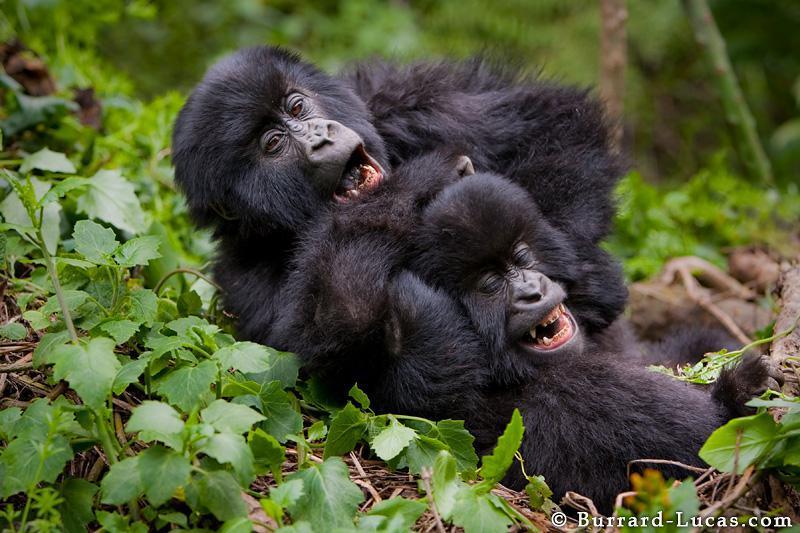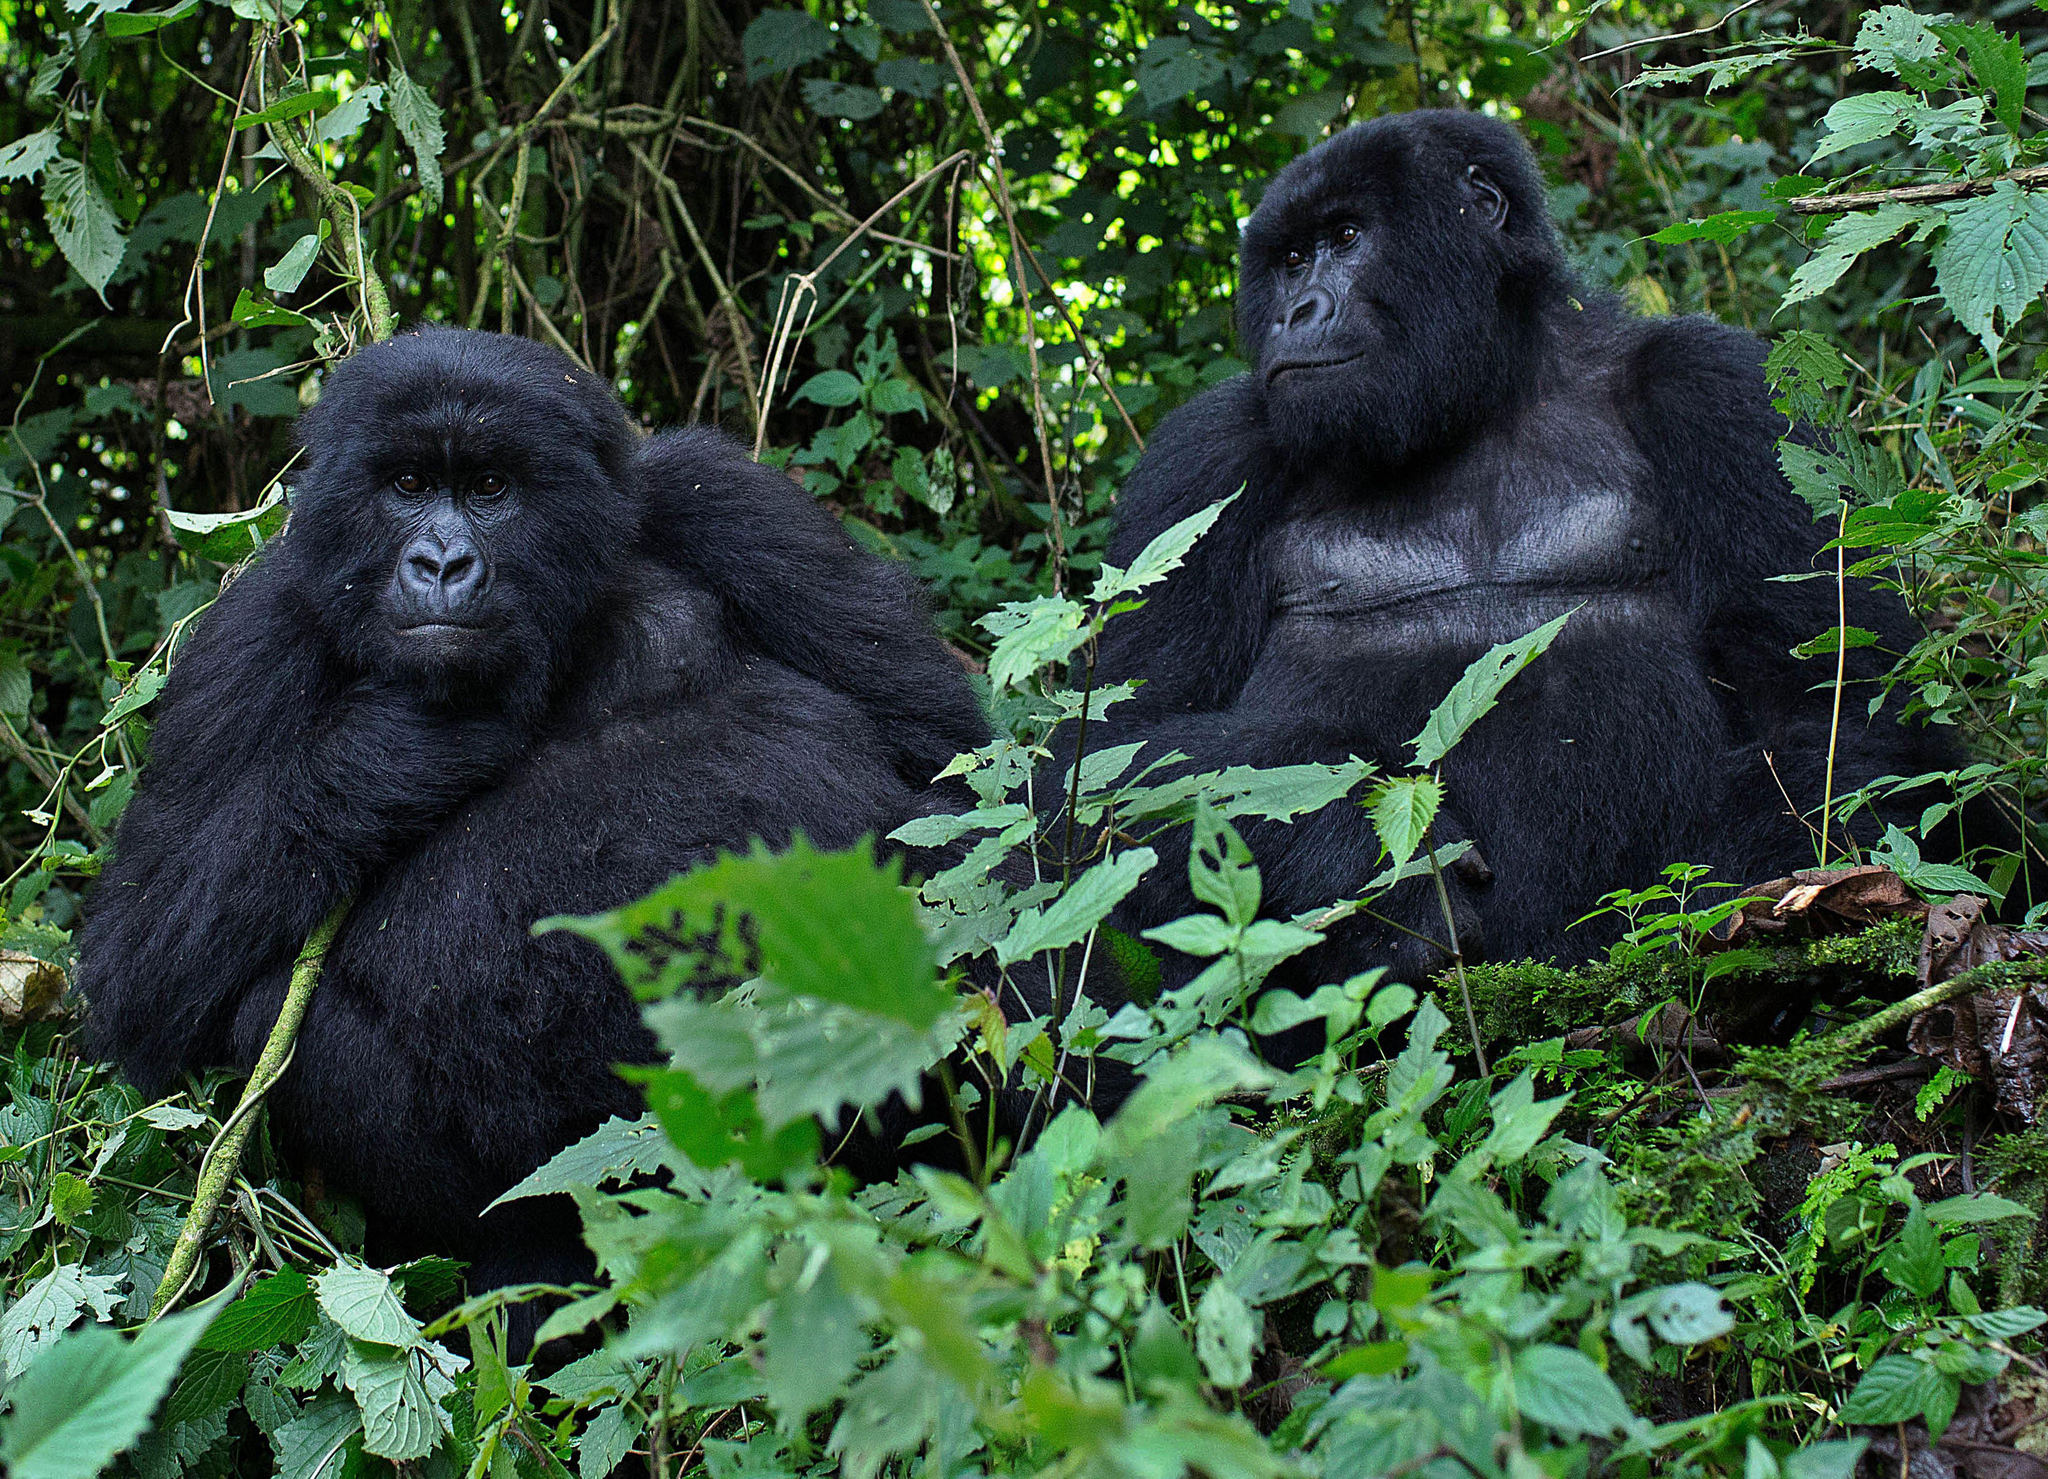The first image is the image on the left, the second image is the image on the right. Assess this claim about the two images: "There are no more than two gorillas in the right image.". Correct or not? Answer yes or no. Yes. The first image is the image on the left, the second image is the image on the right. For the images displayed, is the sentence "There are adult and juvenile gorillas in each image." factually correct? Answer yes or no. No. 